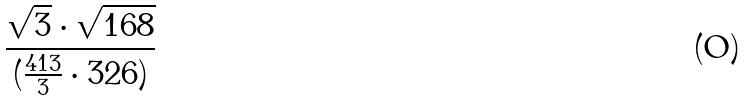Convert formula to latex. <formula><loc_0><loc_0><loc_500><loc_500>\frac { \sqrt { 3 } \cdot \sqrt { 1 6 8 } } { ( \frac { 4 1 3 } { 3 } \cdot 3 2 6 ) }</formula> 